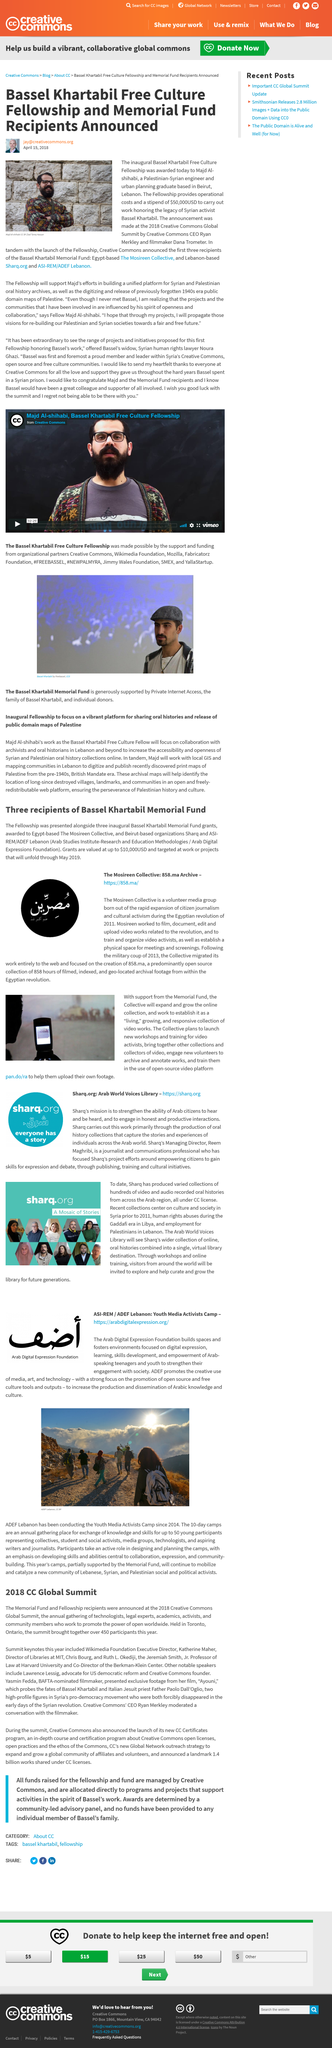Mention a couple of crucial points in this snapshot. Yasmin Fedda presented exclusive film footage at the 2018 CC Global Summit. After the military coup of 2013, the Mosireen Collective migrated its work to the web. Sharp and ASI-REM/ADEF Lebanon are based in Beirut. The efforts of Sharq aim to empower citizens by focusing on developing skills for expression and debate through publishing, training, and cultural initiatives. Creative Commons CEO Ryan Merkley moderated a conversation with Yasmin Fedda. 